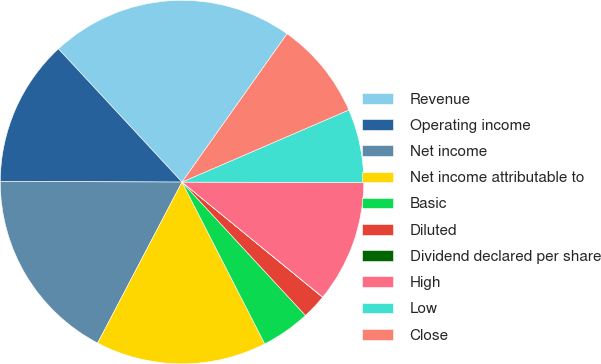<chart> <loc_0><loc_0><loc_500><loc_500><pie_chart><fcel>Revenue<fcel>Operating income<fcel>Net income<fcel>Net income attributable to<fcel>Basic<fcel>Diluted<fcel>Dividend declared per share<fcel>High<fcel>Low<fcel>Close<nl><fcel>21.72%<fcel>13.04%<fcel>17.38%<fcel>15.21%<fcel>4.36%<fcel>2.19%<fcel>0.02%<fcel>10.87%<fcel>6.53%<fcel>8.7%<nl></chart> 